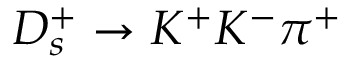Convert formula to latex. <formula><loc_0><loc_0><loc_500><loc_500>D _ { s } ^ { + } \to K ^ { + } K ^ { - } \pi ^ { + }</formula> 